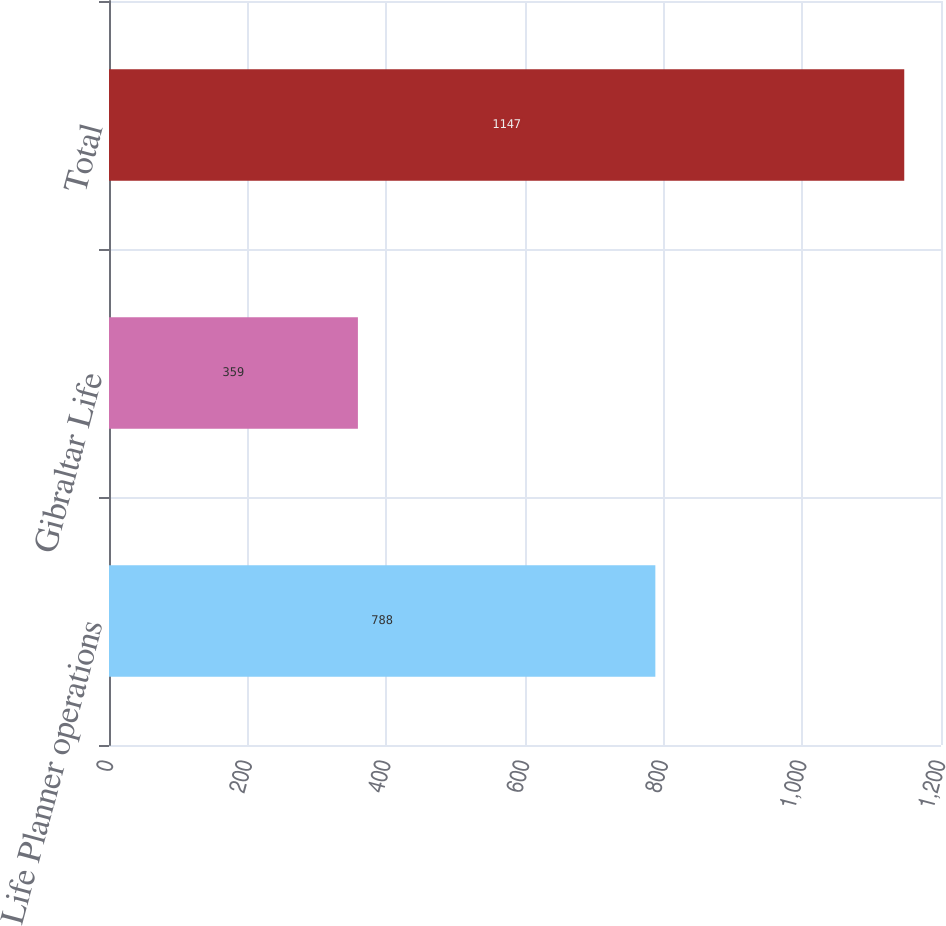Convert chart. <chart><loc_0><loc_0><loc_500><loc_500><bar_chart><fcel>Life Planner operations<fcel>Gibraltar Life<fcel>Total<nl><fcel>788<fcel>359<fcel>1147<nl></chart> 